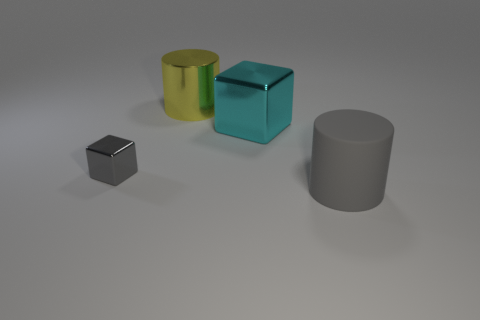There is a yellow thing that is the same shape as the gray rubber thing; what is it made of?
Your answer should be compact. Metal. Are there more cubes that are in front of the large cyan metallic block than green rubber spheres?
Give a very brief answer. Yes. Are there any other things that are the same color as the big block?
Your answer should be compact. No. What is the shape of the large cyan object that is made of the same material as the small gray cube?
Provide a short and direct response. Cube. Do the large cylinder that is in front of the large cyan metal cube and the big cyan cube have the same material?
Your answer should be very brief. No. There is a small metallic thing that is the same color as the matte cylinder; what shape is it?
Offer a terse response. Cube. Do the big cylinder behind the gray matte object and the small metal cube behind the gray rubber thing have the same color?
Ensure brevity in your answer.  No. What number of things are both right of the gray metal thing and in front of the cyan metal thing?
Keep it short and to the point. 1. What is the material of the yellow thing?
Give a very brief answer. Metal. The gray thing that is the same size as the metal cylinder is what shape?
Offer a terse response. Cylinder. 